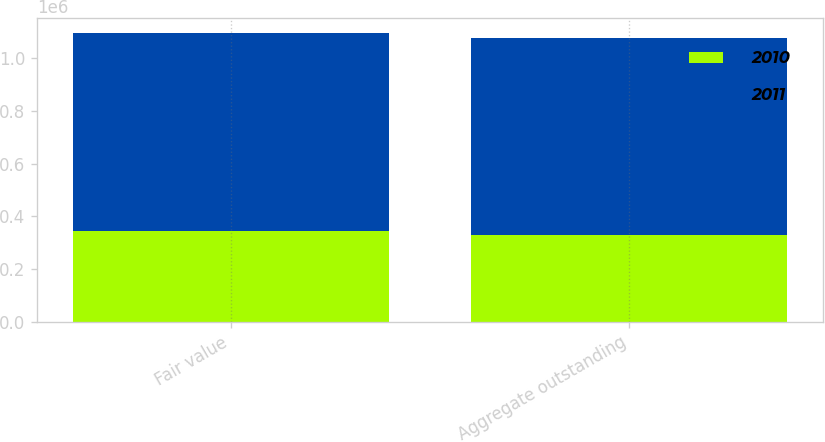<chart> <loc_0><loc_0><loc_500><loc_500><stacked_bar_chart><ecel><fcel>Fair value<fcel>Aggregate outstanding<nl><fcel>2010<fcel>343588<fcel>328641<nl><fcel>2011<fcel>754117<fcel>749982<nl></chart> 